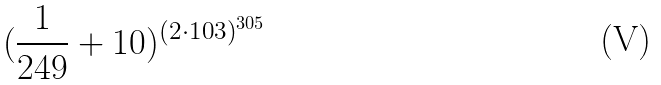Convert formula to latex. <formula><loc_0><loc_0><loc_500><loc_500>( \frac { 1 } { 2 4 9 } + 1 0 ) ^ { ( 2 \cdot 1 0 3 ) ^ { 3 0 5 } }</formula> 